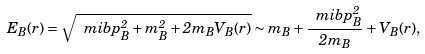Convert formula to latex. <formula><loc_0><loc_0><loc_500><loc_500>E _ { B } ( r ) = \sqrt { \ m i b p _ { B } ^ { 2 } + m _ { B } ^ { 2 } + 2 m _ { B } V _ { B } ( r ) } \sim m _ { B } + \frac { \ m i b p _ { B } ^ { 2 } } { 2 m _ { B } } + V _ { B } ( r ) ,</formula> 